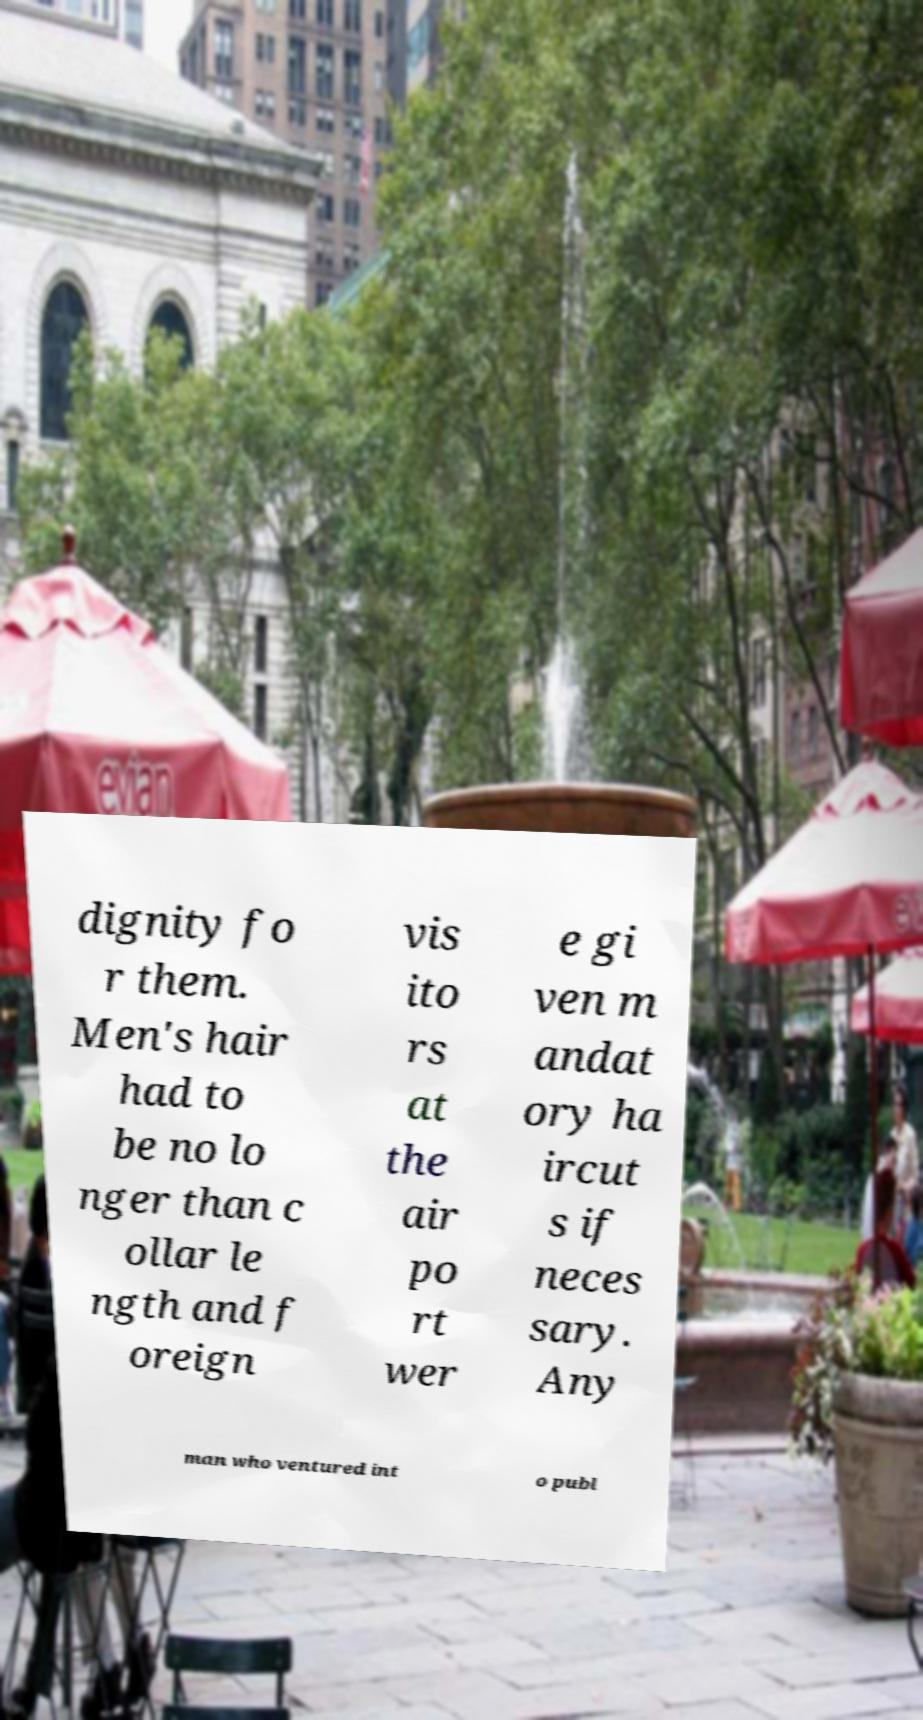Could you assist in decoding the text presented in this image and type it out clearly? dignity fo r them. Men's hair had to be no lo nger than c ollar le ngth and f oreign vis ito rs at the air po rt wer e gi ven m andat ory ha ircut s if neces sary. Any man who ventured int o publ 